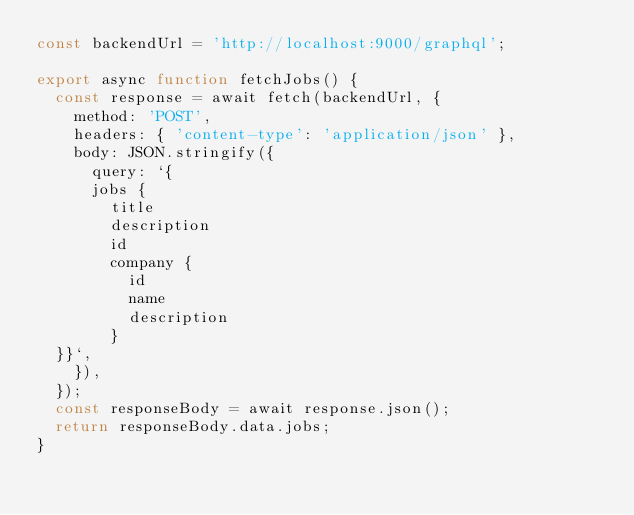Convert code to text. <code><loc_0><loc_0><loc_500><loc_500><_JavaScript_>const backendUrl = 'http://localhost:9000/graphql';

export async function fetchJobs() {
  const response = await fetch(backendUrl, {
    method: 'POST',
    headers: { 'content-type': 'application/json' },
    body: JSON.stringify({
      query: `{
      jobs {
        title
        description
        id
        company {
          id
          name
          description
        }
  }}`,
    }),
  });
  const responseBody = await response.json();
  return responseBody.data.jobs;
}
</code> 